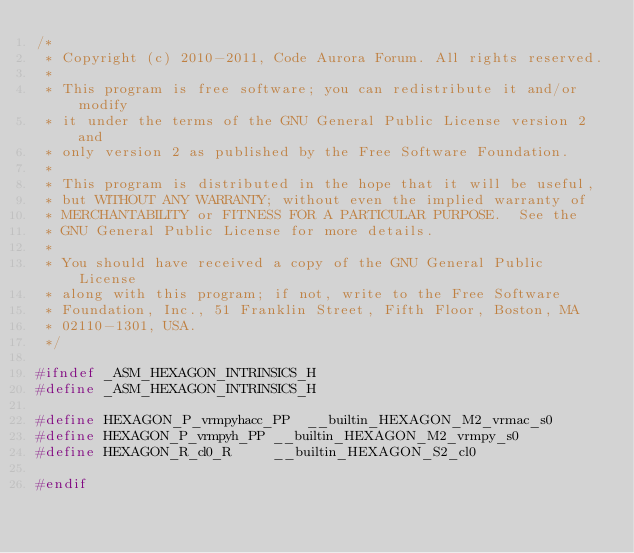Convert code to text. <code><loc_0><loc_0><loc_500><loc_500><_C_>/*
 * Copyright (c) 2010-2011, Code Aurora Forum. All rights reserved.
 *
 * This program is free software; you can redistribute it and/or modify
 * it under the terms of the GNU General Public License version 2 and
 * only version 2 as published by the Free Software Foundation.
 *
 * This program is distributed in the hope that it will be useful,
 * but WITHOUT ANY WARRANTY; without even the implied warranty of
 * MERCHANTABILITY or FITNESS FOR A PARTICULAR PURPOSE.  See the
 * GNU General Public License for more details.
 *
 * You should have received a copy of the GNU General Public License
 * along with this program; if not, write to the Free Software
 * Foundation, Inc., 51 Franklin Street, Fifth Floor, Boston, MA
 * 02110-1301, USA.
 */

#ifndef _ASM_HEXAGON_INTRINSICS_H
#define _ASM_HEXAGON_INTRINSICS_H

#define HEXAGON_P_vrmpyhacc_PP	__builtin_HEXAGON_M2_vrmac_s0
#define HEXAGON_P_vrmpyh_PP	__builtin_HEXAGON_M2_vrmpy_s0
#define HEXAGON_R_cl0_R		__builtin_HEXAGON_S2_cl0

#endif
</code> 